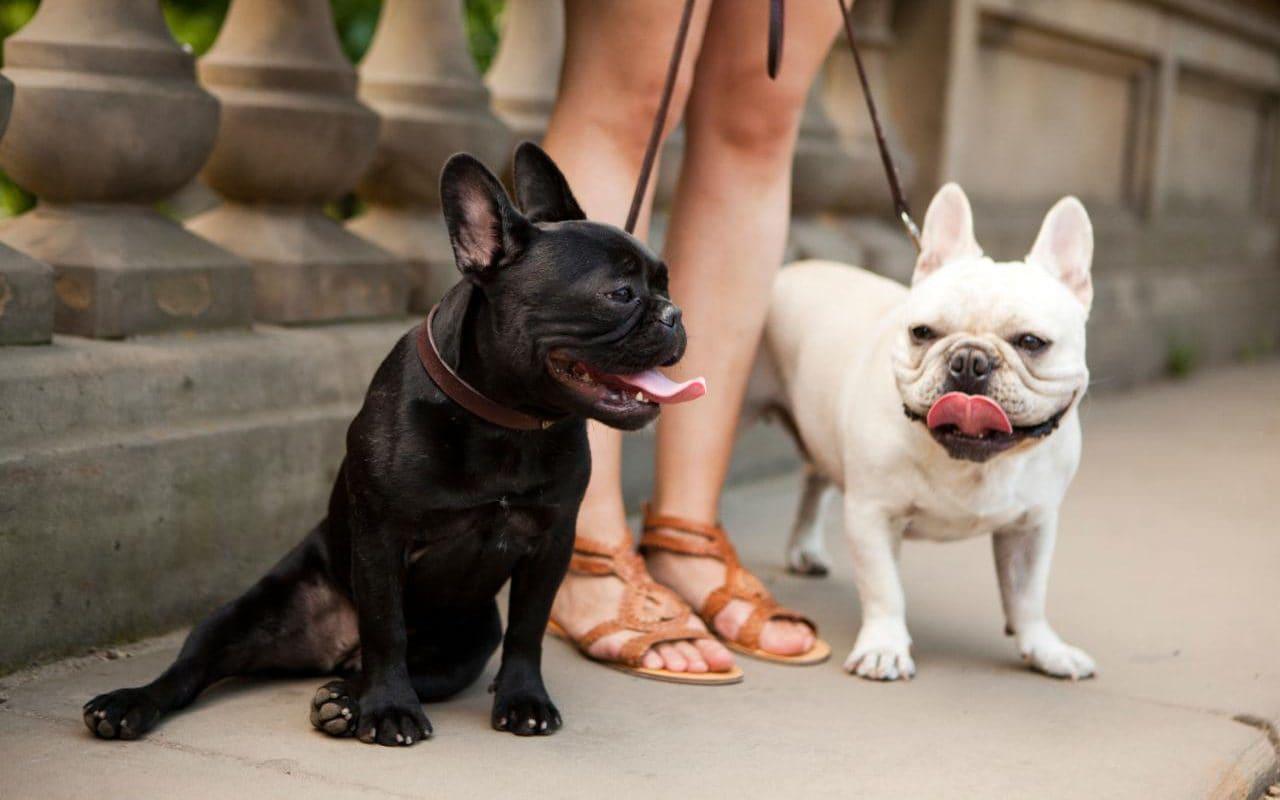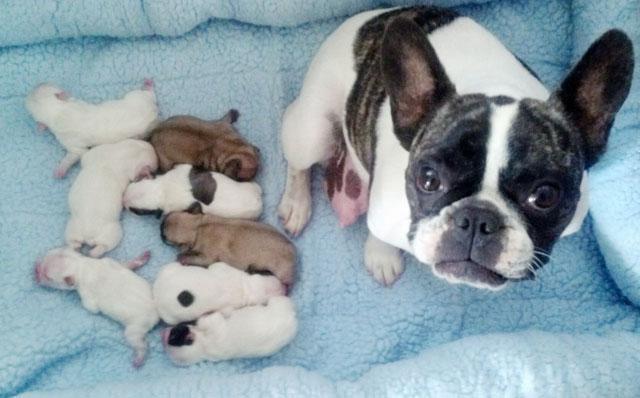The first image is the image on the left, the second image is the image on the right. Analyze the images presented: Is the assertion "There are two puppies in the right image." valid? Answer yes or no. No. The first image is the image on the left, the second image is the image on the right. Considering the images on both sides, is "There are two black nose puppy bull dogs off leash looking forward." valid? Answer yes or no. No. 